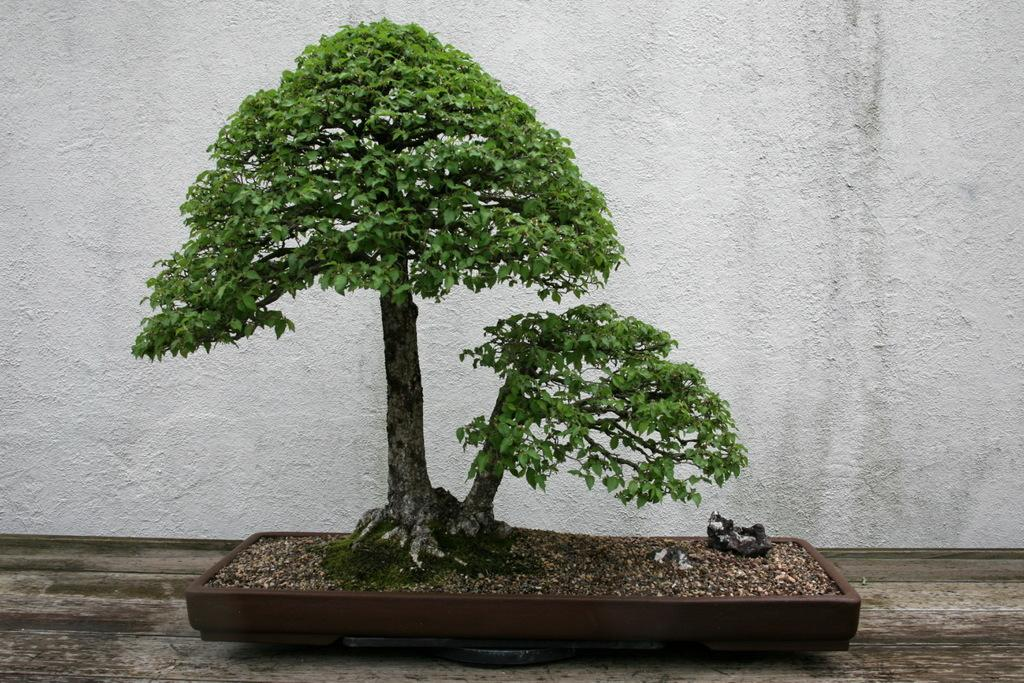What type of tree is in the image? There is an artificial tree in the image. How is the artificial tree positioned? The artificial tree is placed in a basket. Where is the basket located? The basket is placed on the floor. What can be seen in the background of the image? There is a wall in the background of the image. What type of oatmeal is being served at the airport in the image? There is no oatmeal or airport present in the image; it features an artificial tree in a basket on the floor with a wall in the background. Is the collar of the dog visible in the image? There is no dog or collar present in the image. 